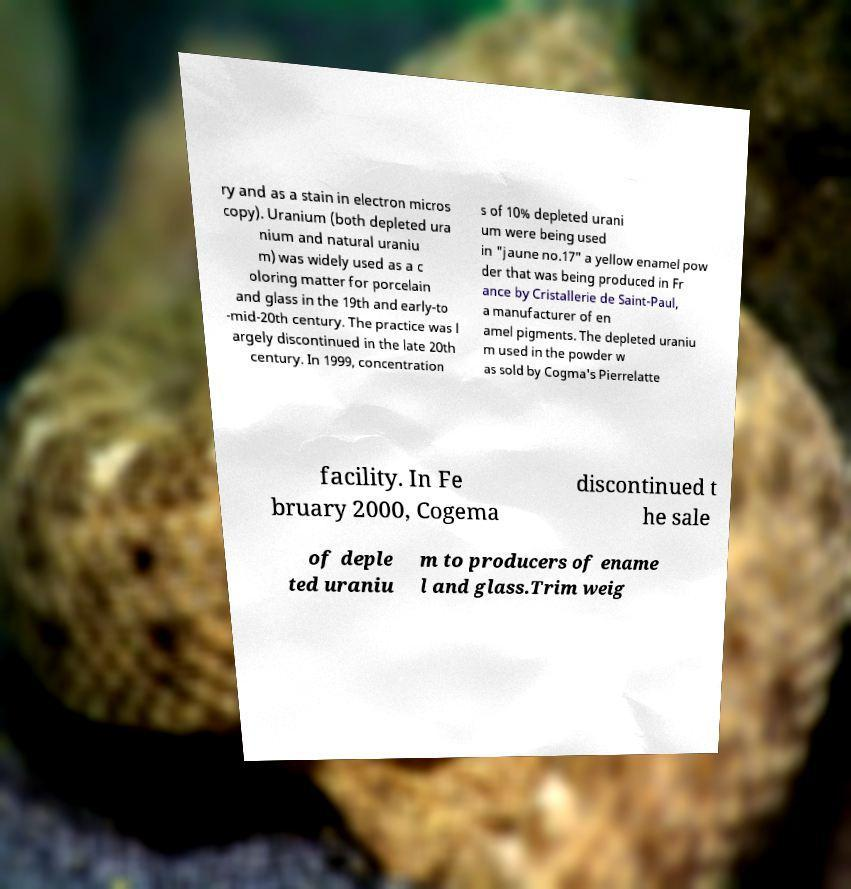Can you accurately transcribe the text from the provided image for me? ry and as a stain in electron micros copy). Uranium (both depleted ura nium and natural uraniu m) was widely used as a c oloring matter for porcelain and glass in the 19th and early-to -mid-20th century. The practice was l argely discontinued in the late 20th century. In 1999, concentration s of 10% depleted urani um were being used in "jaune no.17" a yellow enamel pow der that was being produced in Fr ance by Cristallerie de Saint-Paul, a manufacturer of en amel pigments. The depleted uraniu m used in the powder w as sold by Cogma's Pierrelatte facility. In Fe bruary 2000, Cogema discontinued t he sale of deple ted uraniu m to producers of ename l and glass.Trim weig 